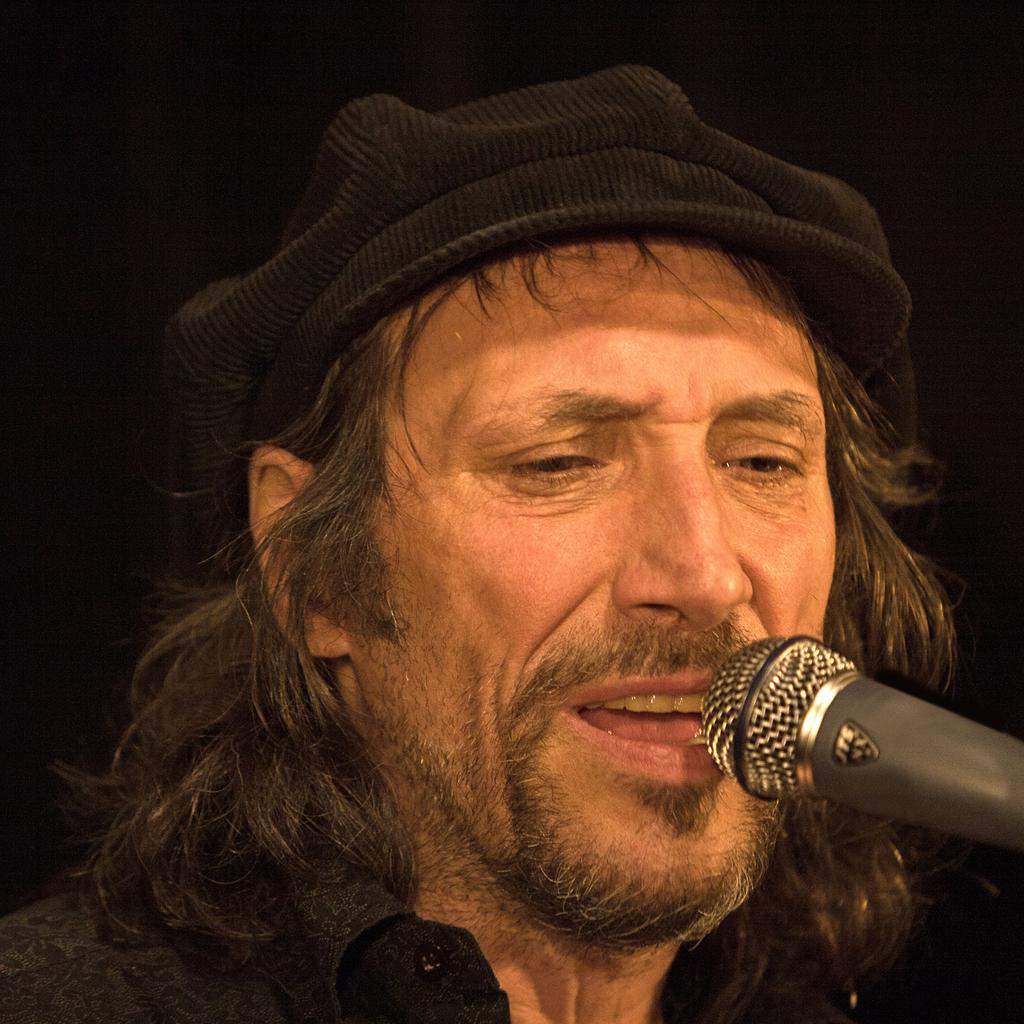Who is the main subject in the image? There is a man in the image. What is the man wearing on his head? The man is wearing a black cap. What object is in front of the man? There is a microphone (mic) in front of the man. What can be observed about the background of the image? The background of the image is dark. How many clovers are growing on the man's head in the image? There are no clovers visible on the man's head in the image. What type of icicle can be seen hanging from the microphone in the image? There is no icicle present in the image; it is indoors and the background is dark. 